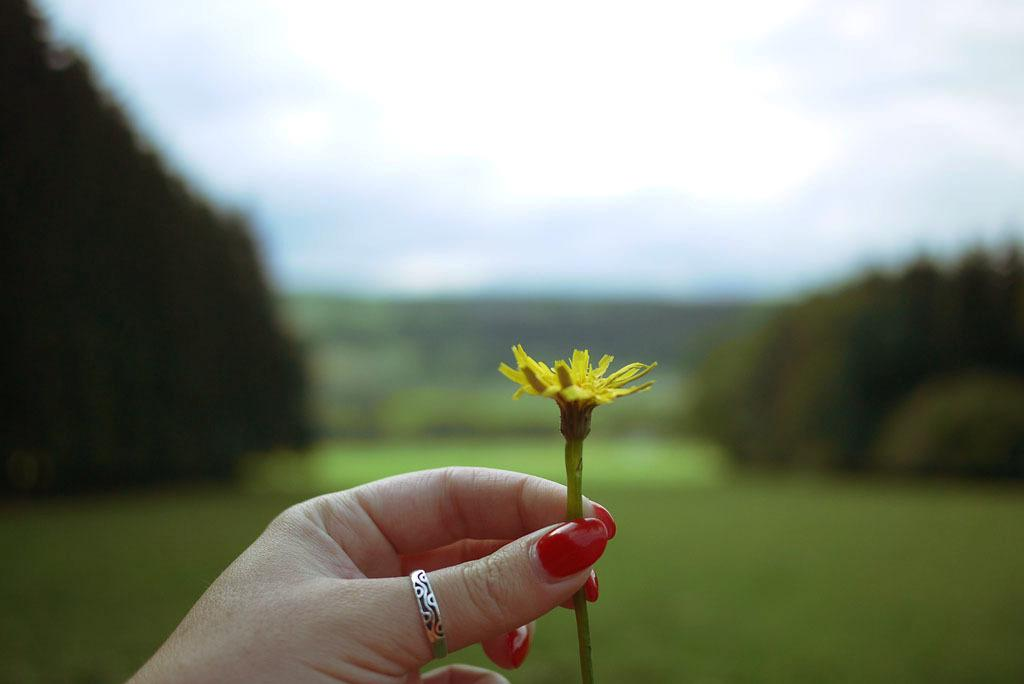What is the person's hand holding in the image? There is a person's hand holding a flower in the image. Can you describe any jewelry on the person's hand? There is a ring on the person's finger. What can be observed about the background of the image? The background of the image is blurry. What type of chicken is visible in the image? There is no chicken present in the image. How does the pollution affect the person holding the flower in the image? The image does not provide any information about pollution, so it cannot be determined how it might affect the person holding the flower. 